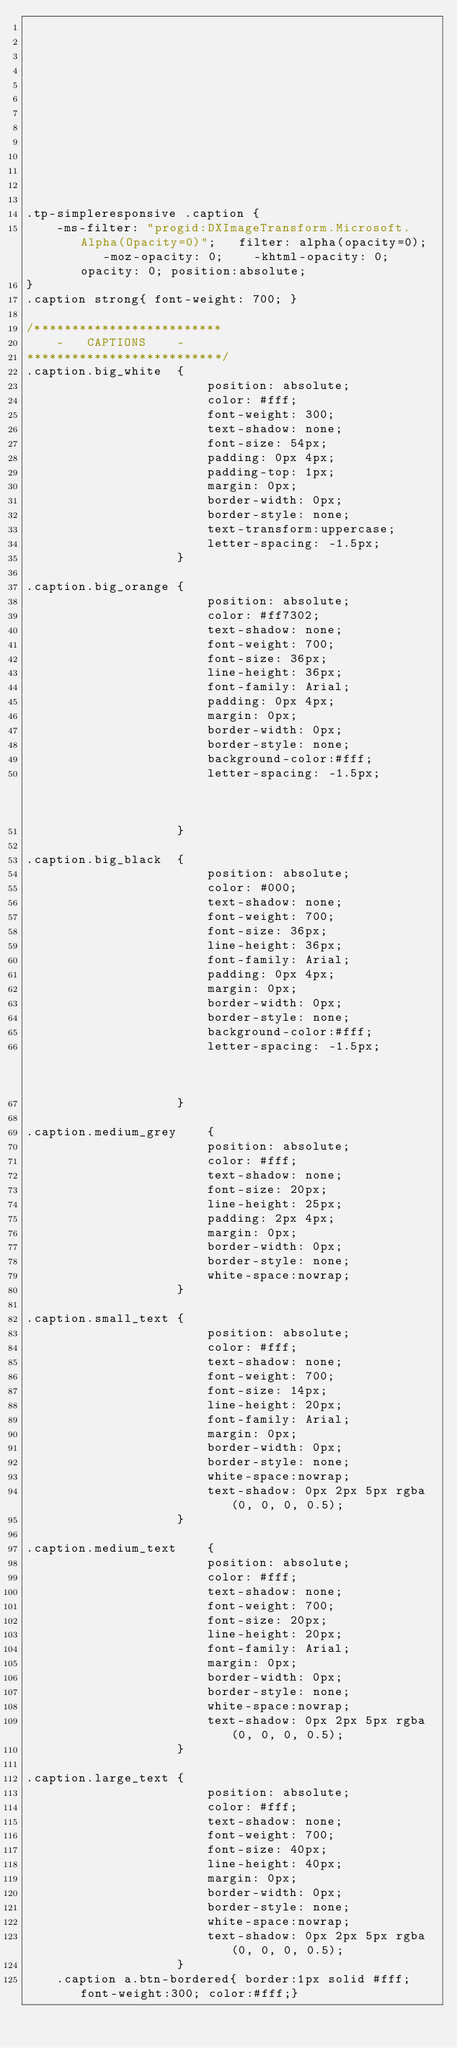<code> <loc_0><loc_0><loc_500><loc_500><_CSS_>












.tp-simpleresponsive .caption {
	-ms-filter: "progid:DXImageTransform.Microsoft.Alpha(Opacity=0)";	filter: alpha(opacity=0);	-moz-opacity: 0;	-khtml-opacity: 0;	opacity: 0; position:absolute;
}
.caption strong{ font-weight: 700; }

/*************************
	-	CAPTIONS	-
**************************/
.caption.big_white	{
						position: absolute; 
						color: #fff;
						font-weight: 300;
						text-shadow: none; 
						font-size: 54px; 
						padding: 0px 4px; 
						padding-top: 1px;
						margin: 0px; 
						border-width: 0px; 
						border-style: none; 
						text-transform:uppercase;	
						letter-spacing: -1.5px;
					}

.caption.big_orange	{
						position: absolute; 
						color: #ff7302; 
						text-shadow: none; 
						font-weight: 700; 
						font-size: 36px; 
						line-height: 36px; 
						font-family: Arial; 
						padding: 0px 4px; 
						margin: 0px; 
						border-width: 0px; 
						border-style: none; 
						background-color:#fff;	
						letter-spacing: -1.5px;															
					}	
					
.caption.big_black	{
						position: absolute; 
						color: #000; 
						text-shadow: none; 
						font-weight: 700; 
						font-size: 36px; 
						line-height: 36px; 
						font-family: Arial; 
						padding: 0px 4px; 
						margin: 0px; 
						border-width: 0px; 
						border-style: none; 
						background-color:#fff;	
						letter-spacing: -1.5px;															
					}		

.caption.medium_grey	{
						position: absolute; 
						color: #fff; 
						text-shadow: none; 
						font-size: 20px; 
						line-height: 25px; 
						padding: 2px 4px; 
						margin: 0px; 
						border-width: 0px; 
						border-style: none; 
						white-space:nowrap;
					}	
					
.caption.small_text	{
						position: absolute; 
						color: #fff; 
						text-shadow: none; 
						font-weight: 700; 
						font-size: 14px; 
						line-height: 20px; 
						font-family: Arial; 
						margin: 0px; 
						border-width: 0px; 
						border-style: none; 
						white-space:nowrap;	
						text-shadow: 0px 2px 5px rgba(0, 0, 0, 0.5);		
					}
					
.caption.medium_text	{
						position: absolute; 
						color: #fff; 
						text-shadow: none; 
						font-weight: 700; 
						font-size: 20px; 
						line-height: 20px; 
						font-family: Arial; 
						margin: 0px; 
						border-width: 0px; 
						border-style: none; 
						white-space:nowrap;	
						text-shadow: 0px 2px 5px rgba(0, 0, 0, 0.5);		
					}
					
.caption.large_text	{
						position: absolute; 
						color: #fff; 
						text-shadow: none; 
						font-weight: 700; 
						font-size: 40px; 
						line-height: 40px; 
						margin: 0px; 
						border-width: 0px; 
						border-style: none; 
						white-space:nowrap;	
						text-shadow: 0px 2px 5px rgba(0, 0, 0, 0.5);		
					}	
	.caption a.btn-bordered{ border:1px solid #fff;font-weight:300; color:#fff;}				</code> 